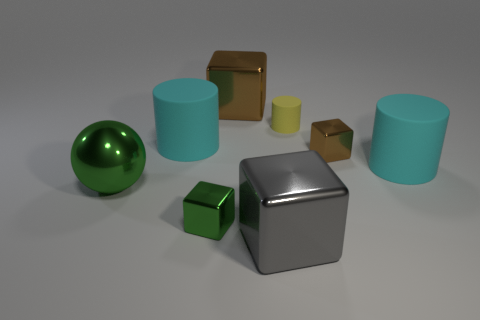What materials do the objects in the image appear to be made of? The objects in the image exhibit a variety of materials. The sphere and the two cylinders appear to have a shiny, reflective surface, suggesting they could be made of a polished metal or a plastic with a metallic finish. The cube in the center looks matte and metallic, possibly steel or aluminum. The small yellow and tiny green cubes seem matte, perhaps resembling painted wood or a matte plastic. 